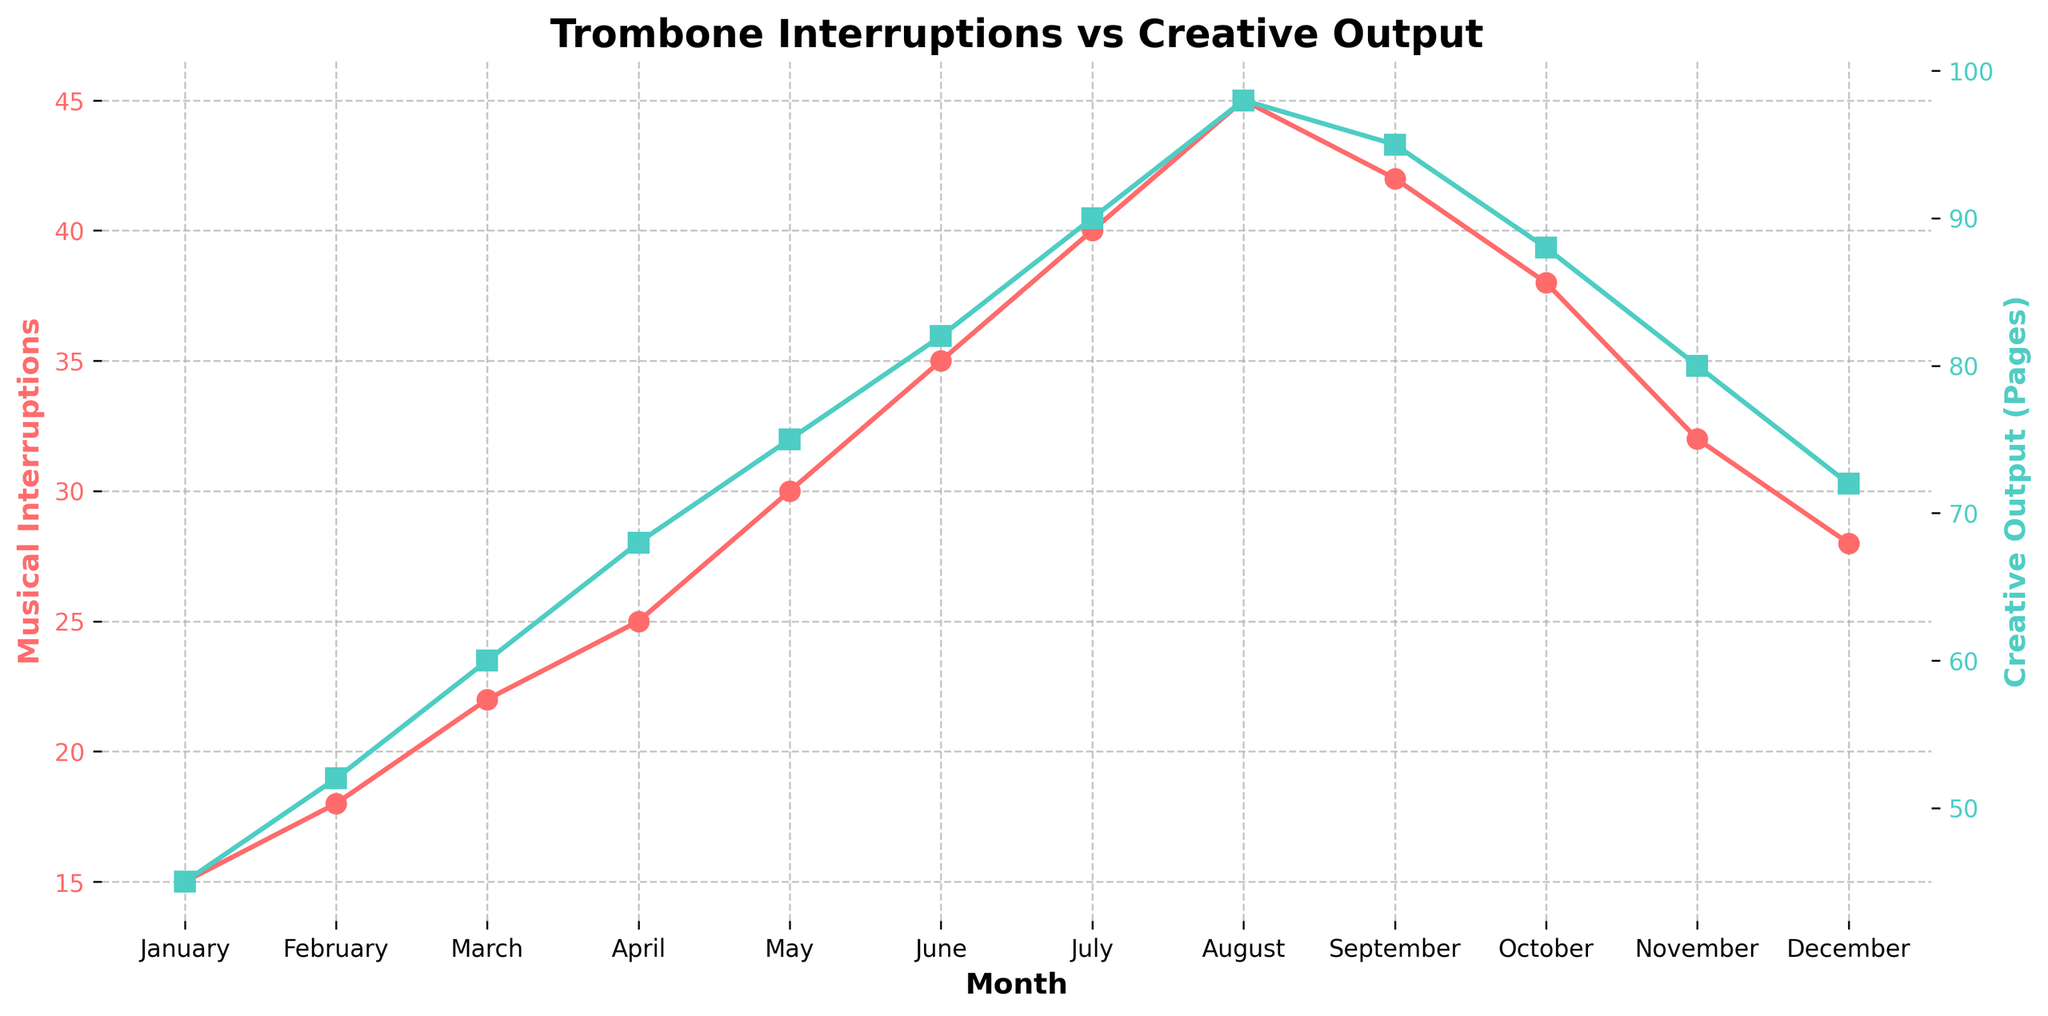What's the month with the highest number of musical interruptions? The month with the highest number of musical interruptions has the peak value on the Musical Interruptions curve. Looking at the red line, August has the highest point with 45 interruptions.
Answer: August By how many pages does creative output increase from January to July? In January, the creative output is 45 pages, and in July, it is 90 pages. The increase is calculated by subtracting January's output from July's: 90 - 45 = 45 pages.
Answer: 45 pages During which month do the musical interruptions start to decrease? The musical interruptions are increasing until August and then start to decrease in September, where they drop from 45 in August to 42 in September.
Answer: September How does the creative output in December compare to that in January? In December, the creative output is 72 pages, while in January it is 45 pages. The comparison shows that December has a higher creative output by 27 pages (72 - 45).
Answer: 27 pages higher What is the overall trend for musical interruptions over the year? The overall trend for musical interruptions sees a steady increase from January until August, after which it decreases towards December.
Answer: Increase then decrease What is the difference in creative output between the peak month and the lowest month? The peak creative output occurs in August with 98 pages, and the lowest in January with 45 pages. The difference is calculated as 98 - 45 = 53 pages.
Answer: 53 pages Which month has almost the same number of musical interruptions and creative output (pages)? The month where both curves are closest is September. Musical interruptions are 42, and creative output is 95, which are relatively closer than other months if not same.
Answer: September What is the visual color representation for creative output as shown in the chart? The creative output is represented by the green color in the dual-axis line chart.
Answer: Green What are the creative outputs for the months when musical interruptions exceed 30? The months with more than 30 musical interruptions are June (35), July (40), August (45), and September (42). The corresponding creative outputs are June (82), July (90), August (98), and September (95).
Answer: 82, 90, 98, 95 